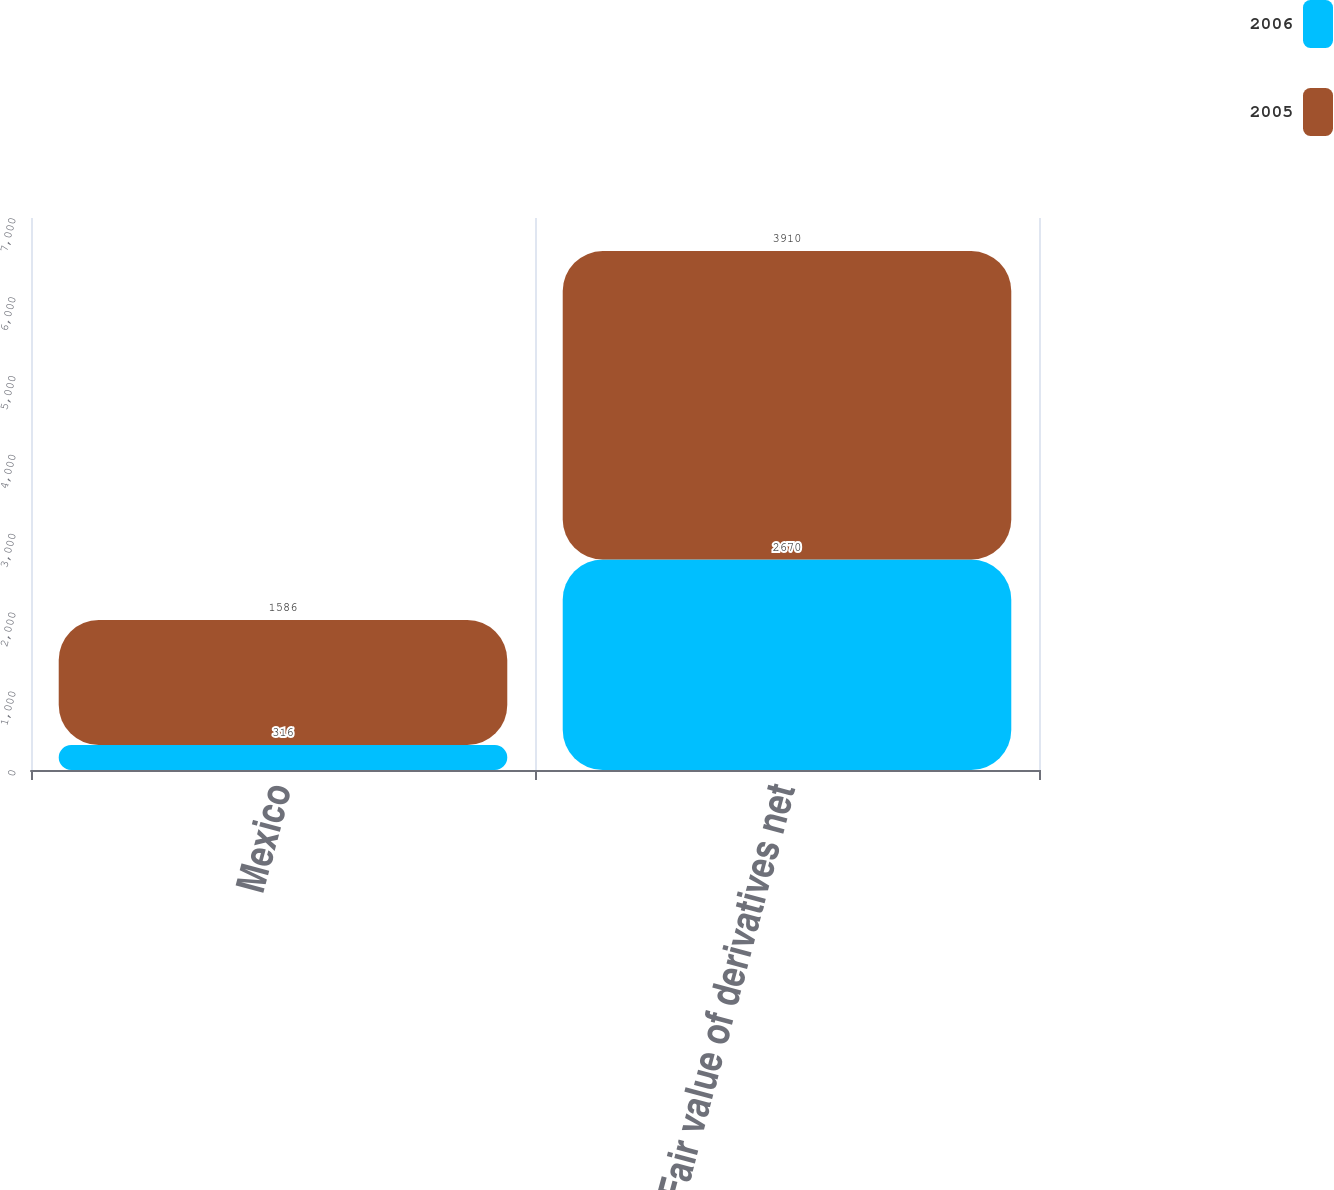Convert chart to OTSL. <chart><loc_0><loc_0><loc_500><loc_500><stacked_bar_chart><ecel><fcel>Mexico<fcel>Fair value of derivatives net<nl><fcel>2006<fcel>316<fcel>2670<nl><fcel>2005<fcel>1586<fcel>3910<nl></chart> 